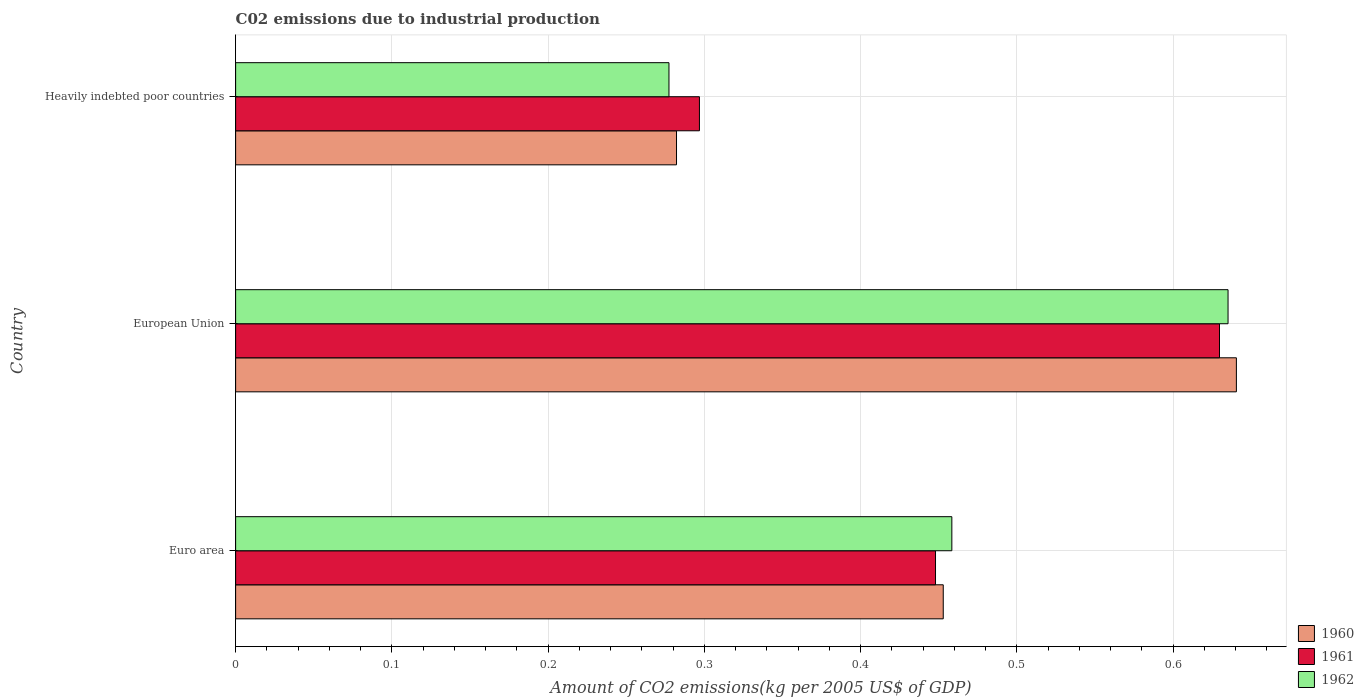How many groups of bars are there?
Provide a short and direct response. 3. Are the number of bars per tick equal to the number of legend labels?
Your answer should be compact. Yes. In how many cases, is the number of bars for a given country not equal to the number of legend labels?
Offer a terse response. 0. What is the amount of CO2 emitted due to industrial production in 1962 in European Union?
Give a very brief answer. 0.64. Across all countries, what is the maximum amount of CO2 emitted due to industrial production in 1961?
Ensure brevity in your answer.  0.63. Across all countries, what is the minimum amount of CO2 emitted due to industrial production in 1962?
Your answer should be very brief. 0.28. In which country was the amount of CO2 emitted due to industrial production in 1962 maximum?
Your answer should be compact. European Union. In which country was the amount of CO2 emitted due to industrial production in 1960 minimum?
Your answer should be very brief. Heavily indebted poor countries. What is the total amount of CO2 emitted due to industrial production in 1960 in the graph?
Ensure brevity in your answer.  1.38. What is the difference between the amount of CO2 emitted due to industrial production in 1962 in Euro area and that in Heavily indebted poor countries?
Give a very brief answer. 0.18. What is the difference between the amount of CO2 emitted due to industrial production in 1962 in Heavily indebted poor countries and the amount of CO2 emitted due to industrial production in 1960 in European Union?
Provide a short and direct response. -0.36. What is the average amount of CO2 emitted due to industrial production in 1961 per country?
Your answer should be compact. 0.46. What is the difference between the amount of CO2 emitted due to industrial production in 1960 and amount of CO2 emitted due to industrial production in 1961 in Euro area?
Provide a short and direct response. 0. What is the ratio of the amount of CO2 emitted due to industrial production in 1962 in European Union to that in Heavily indebted poor countries?
Offer a very short reply. 2.29. Is the amount of CO2 emitted due to industrial production in 1961 in European Union less than that in Heavily indebted poor countries?
Your answer should be very brief. No. What is the difference between the highest and the second highest amount of CO2 emitted due to industrial production in 1960?
Give a very brief answer. 0.19. What is the difference between the highest and the lowest amount of CO2 emitted due to industrial production in 1960?
Provide a succinct answer. 0.36. In how many countries, is the amount of CO2 emitted due to industrial production in 1961 greater than the average amount of CO2 emitted due to industrial production in 1961 taken over all countries?
Your response must be concise. 1. What does the 2nd bar from the top in Euro area represents?
Ensure brevity in your answer.  1961. What does the 2nd bar from the bottom in Heavily indebted poor countries represents?
Your answer should be very brief. 1961. Are all the bars in the graph horizontal?
Make the answer very short. Yes. How many countries are there in the graph?
Provide a short and direct response. 3. What is the difference between two consecutive major ticks on the X-axis?
Your response must be concise. 0.1. Are the values on the major ticks of X-axis written in scientific E-notation?
Give a very brief answer. No. Does the graph contain grids?
Your answer should be very brief. Yes. Where does the legend appear in the graph?
Your response must be concise. Bottom right. What is the title of the graph?
Make the answer very short. C02 emissions due to industrial production. Does "1967" appear as one of the legend labels in the graph?
Make the answer very short. No. What is the label or title of the X-axis?
Offer a very short reply. Amount of CO2 emissions(kg per 2005 US$ of GDP). What is the label or title of the Y-axis?
Your response must be concise. Country. What is the Amount of CO2 emissions(kg per 2005 US$ of GDP) of 1960 in Euro area?
Your answer should be compact. 0.45. What is the Amount of CO2 emissions(kg per 2005 US$ of GDP) of 1961 in Euro area?
Make the answer very short. 0.45. What is the Amount of CO2 emissions(kg per 2005 US$ of GDP) in 1962 in Euro area?
Ensure brevity in your answer.  0.46. What is the Amount of CO2 emissions(kg per 2005 US$ of GDP) in 1960 in European Union?
Offer a terse response. 0.64. What is the Amount of CO2 emissions(kg per 2005 US$ of GDP) of 1961 in European Union?
Offer a terse response. 0.63. What is the Amount of CO2 emissions(kg per 2005 US$ of GDP) of 1962 in European Union?
Offer a terse response. 0.64. What is the Amount of CO2 emissions(kg per 2005 US$ of GDP) of 1960 in Heavily indebted poor countries?
Offer a very short reply. 0.28. What is the Amount of CO2 emissions(kg per 2005 US$ of GDP) of 1961 in Heavily indebted poor countries?
Your answer should be compact. 0.3. What is the Amount of CO2 emissions(kg per 2005 US$ of GDP) of 1962 in Heavily indebted poor countries?
Your answer should be very brief. 0.28. Across all countries, what is the maximum Amount of CO2 emissions(kg per 2005 US$ of GDP) in 1960?
Offer a terse response. 0.64. Across all countries, what is the maximum Amount of CO2 emissions(kg per 2005 US$ of GDP) of 1961?
Your answer should be very brief. 0.63. Across all countries, what is the maximum Amount of CO2 emissions(kg per 2005 US$ of GDP) in 1962?
Provide a succinct answer. 0.64. Across all countries, what is the minimum Amount of CO2 emissions(kg per 2005 US$ of GDP) in 1960?
Your response must be concise. 0.28. Across all countries, what is the minimum Amount of CO2 emissions(kg per 2005 US$ of GDP) in 1961?
Your answer should be compact. 0.3. Across all countries, what is the minimum Amount of CO2 emissions(kg per 2005 US$ of GDP) of 1962?
Offer a very short reply. 0.28. What is the total Amount of CO2 emissions(kg per 2005 US$ of GDP) of 1960 in the graph?
Provide a succinct answer. 1.38. What is the total Amount of CO2 emissions(kg per 2005 US$ of GDP) in 1961 in the graph?
Provide a short and direct response. 1.37. What is the total Amount of CO2 emissions(kg per 2005 US$ of GDP) in 1962 in the graph?
Provide a succinct answer. 1.37. What is the difference between the Amount of CO2 emissions(kg per 2005 US$ of GDP) of 1960 in Euro area and that in European Union?
Your answer should be compact. -0.19. What is the difference between the Amount of CO2 emissions(kg per 2005 US$ of GDP) of 1961 in Euro area and that in European Union?
Ensure brevity in your answer.  -0.18. What is the difference between the Amount of CO2 emissions(kg per 2005 US$ of GDP) in 1962 in Euro area and that in European Union?
Your answer should be very brief. -0.18. What is the difference between the Amount of CO2 emissions(kg per 2005 US$ of GDP) of 1960 in Euro area and that in Heavily indebted poor countries?
Your response must be concise. 0.17. What is the difference between the Amount of CO2 emissions(kg per 2005 US$ of GDP) of 1961 in Euro area and that in Heavily indebted poor countries?
Your answer should be very brief. 0.15. What is the difference between the Amount of CO2 emissions(kg per 2005 US$ of GDP) of 1962 in Euro area and that in Heavily indebted poor countries?
Provide a succinct answer. 0.18. What is the difference between the Amount of CO2 emissions(kg per 2005 US$ of GDP) of 1960 in European Union and that in Heavily indebted poor countries?
Give a very brief answer. 0.36. What is the difference between the Amount of CO2 emissions(kg per 2005 US$ of GDP) of 1961 in European Union and that in Heavily indebted poor countries?
Your response must be concise. 0.33. What is the difference between the Amount of CO2 emissions(kg per 2005 US$ of GDP) of 1962 in European Union and that in Heavily indebted poor countries?
Your answer should be compact. 0.36. What is the difference between the Amount of CO2 emissions(kg per 2005 US$ of GDP) of 1960 in Euro area and the Amount of CO2 emissions(kg per 2005 US$ of GDP) of 1961 in European Union?
Provide a short and direct response. -0.18. What is the difference between the Amount of CO2 emissions(kg per 2005 US$ of GDP) in 1960 in Euro area and the Amount of CO2 emissions(kg per 2005 US$ of GDP) in 1962 in European Union?
Your response must be concise. -0.18. What is the difference between the Amount of CO2 emissions(kg per 2005 US$ of GDP) in 1961 in Euro area and the Amount of CO2 emissions(kg per 2005 US$ of GDP) in 1962 in European Union?
Provide a short and direct response. -0.19. What is the difference between the Amount of CO2 emissions(kg per 2005 US$ of GDP) of 1960 in Euro area and the Amount of CO2 emissions(kg per 2005 US$ of GDP) of 1961 in Heavily indebted poor countries?
Offer a very short reply. 0.16. What is the difference between the Amount of CO2 emissions(kg per 2005 US$ of GDP) of 1960 in Euro area and the Amount of CO2 emissions(kg per 2005 US$ of GDP) of 1962 in Heavily indebted poor countries?
Your answer should be compact. 0.18. What is the difference between the Amount of CO2 emissions(kg per 2005 US$ of GDP) in 1961 in Euro area and the Amount of CO2 emissions(kg per 2005 US$ of GDP) in 1962 in Heavily indebted poor countries?
Your response must be concise. 0.17. What is the difference between the Amount of CO2 emissions(kg per 2005 US$ of GDP) of 1960 in European Union and the Amount of CO2 emissions(kg per 2005 US$ of GDP) of 1961 in Heavily indebted poor countries?
Your answer should be compact. 0.34. What is the difference between the Amount of CO2 emissions(kg per 2005 US$ of GDP) in 1960 in European Union and the Amount of CO2 emissions(kg per 2005 US$ of GDP) in 1962 in Heavily indebted poor countries?
Provide a short and direct response. 0.36. What is the difference between the Amount of CO2 emissions(kg per 2005 US$ of GDP) in 1961 in European Union and the Amount of CO2 emissions(kg per 2005 US$ of GDP) in 1962 in Heavily indebted poor countries?
Provide a succinct answer. 0.35. What is the average Amount of CO2 emissions(kg per 2005 US$ of GDP) of 1960 per country?
Provide a succinct answer. 0.46. What is the average Amount of CO2 emissions(kg per 2005 US$ of GDP) in 1961 per country?
Provide a succinct answer. 0.46. What is the average Amount of CO2 emissions(kg per 2005 US$ of GDP) in 1962 per country?
Give a very brief answer. 0.46. What is the difference between the Amount of CO2 emissions(kg per 2005 US$ of GDP) of 1960 and Amount of CO2 emissions(kg per 2005 US$ of GDP) of 1961 in Euro area?
Your answer should be very brief. 0. What is the difference between the Amount of CO2 emissions(kg per 2005 US$ of GDP) of 1960 and Amount of CO2 emissions(kg per 2005 US$ of GDP) of 1962 in Euro area?
Keep it short and to the point. -0.01. What is the difference between the Amount of CO2 emissions(kg per 2005 US$ of GDP) of 1961 and Amount of CO2 emissions(kg per 2005 US$ of GDP) of 1962 in Euro area?
Provide a short and direct response. -0.01. What is the difference between the Amount of CO2 emissions(kg per 2005 US$ of GDP) of 1960 and Amount of CO2 emissions(kg per 2005 US$ of GDP) of 1961 in European Union?
Provide a succinct answer. 0.01. What is the difference between the Amount of CO2 emissions(kg per 2005 US$ of GDP) in 1960 and Amount of CO2 emissions(kg per 2005 US$ of GDP) in 1962 in European Union?
Provide a short and direct response. 0.01. What is the difference between the Amount of CO2 emissions(kg per 2005 US$ of GDP) in 1961 and Amount of CO2 emissions(kg per 2005 US$ of GDP) in 1962 in European Union?
Make the answer very short. -0.01. What is the difference between the Amount of CO2 emissions(kg per 2005 US$ of GDP) in 1960 and Amount of CO2 emissions(kg per 2005 US$ of GDP) in 1961 in Heavily indebted poor countries?
Your answer should be very brief. -0.01. What is the difference between the Amount of CO2 emissions(kg per 2005 US$ of GDP) in 1960 and Amount of CO2 emissions(kg per 2005 US$ of GDP) in 1962 in Heavily indebted poor countries?
Offer a very short reply. 0. What is the difference between the Amount of CO2 emissions(kg per 2005 US$ of GDP) of 1961 and Amount of CO2 emissions(kg per 2005 US$ of GDP) of 1962 in Heavily indebted poor countries?
Provide a succinct answer. 0.02. What is the ratio of the Amount of CO2 emissions(kg per 2005 US$ of GDP) in 1960 in Euro area to that in European Union?
Offer a very short reply. 0.71. What is the ratio of the Amount of CO2 emissions(kg per 2005 US$ of GDP) of 1961 in Euro area to that in European Union?
Keep it short and to the point. 0.71. What is the ratio of the Amount of CO2 emissions(kg per 2005 US$ of GDP) in 1962 in Euro area to that in European Union?
Offer a very short reply. 0.72. What is the ratio of the Amount of CO2 emissions(kg per 2005 US$ of GDP) of 1960 in Euro area to that in Heavily indebted poor countries?
Provide a succinct answer. 1.6. What is the ratio of the Amount of CO2 emissions(kg per 2005 US$ of GDP) in 1961 in Euro area to that in Heavily indebted poor countries?
Make the answer very short. 1.51. What is the ratio of the Amount of CO2 emissions(kg per 2005 US$ of GDP) in 1962 in Euro area to that in Heavily indebted poor countries?
Make the answer very short. 1.65. What is the ratio of the Amount of CO2 emissions(kg per 2005 US$ of GDP) in 1960 in European Union to that in Heavily indebted poor countries?
Your answer should be very brief. 2.27. What is the ratio of the Amount of CO2 emissions(kg per 2005 US$ of GDP) in 1961 in European Union to that in Heavily indebted poor countries?
Give a very brief answer. 2.12. What is the ratio of the Amount of CO2 emissions(kg per 2005 US$ of GDP) in 1962 in European Union to that in Heavily indebted poor countries?
Offer a terse response. 2.29. What is the difference between the highest and the second highest Amount of CO2 emissions(kg per 2005 US$ of GDP) of 1960?
Offer a terse response. 0.19. What is the difference between the highest and the second highest Amount of CO2 emissions(kg per 2005 US$ of GDP) of 1961?
Ensure brevity in your answer.  0.18. What is the difference between the highest and the second highest Amount of CO2 emissions(kg per 2005 US$ of GDP) of 1962?
Provide a short and direct response. 0.18. What is the difference between the highest and the lowest Amount of CO2 emissions(kg per 2005 US$ of GDP) of 1960?
Make the answer very short. 0.36. What is the difference between the highest and the lowest Amount of CO2 emissions(kg per 2005 US$ of GDP) of 1961?
Your answer should be very brief. 0.33. What is the difference between the highest and the lowest Amount of CO2 emissions(kg per 2005 US$ of GDP) of 1962?
Ensure brevity in your answer.  0.36. 